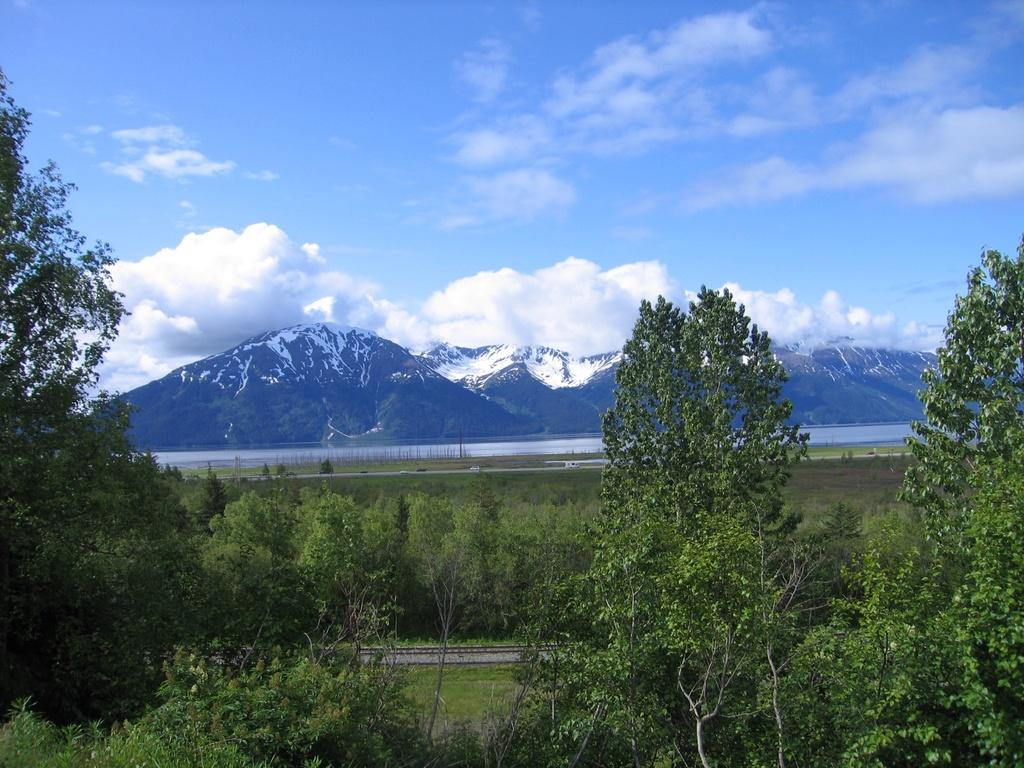What is the main feature in the center of the image? There is a railway track in the center of the image. What type of vegetation can be seen in the image? There are trees in the image. What natural element is visible in the image? There is water visible in the image. What is the condition of the mountains in the image? There is snow on the mountains in the image. What can be seen in the background of the image? The sky is visible in the background of the image. How does the trick help the water flow faster in the image? There is no trick mentioned in the image, and the water flow is not discussed. 